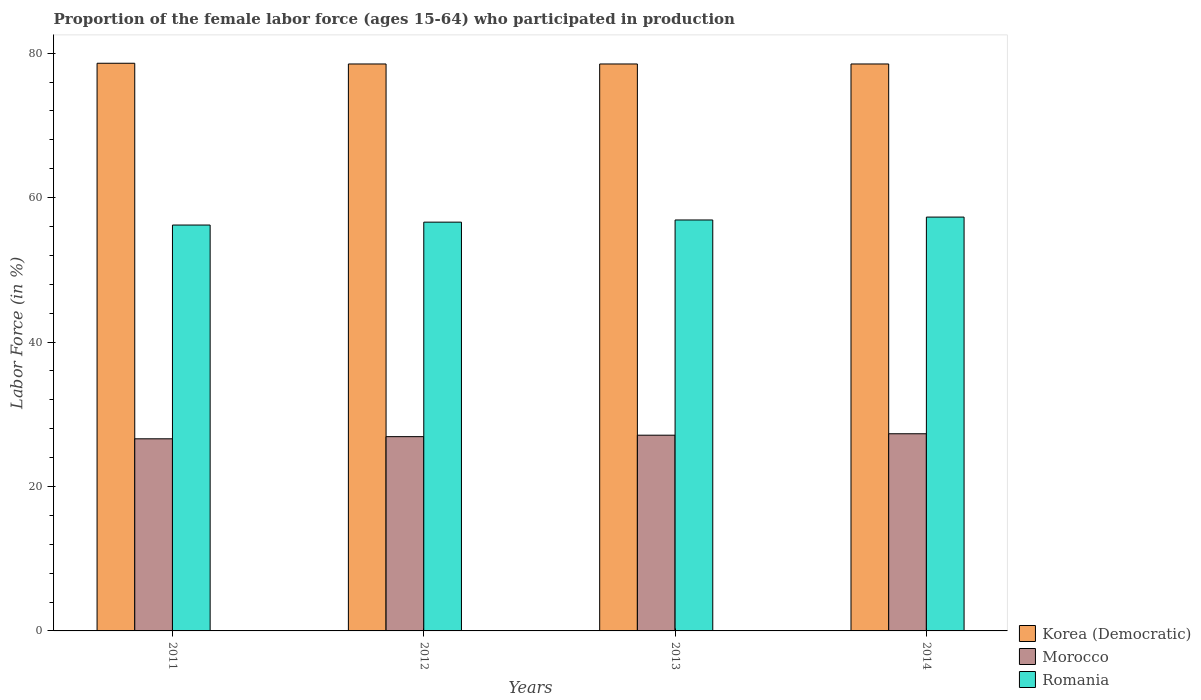How many groups of bars are there?
Keep it short and to the point. 4. What is the label of the 2nd group of bars from the left?
Offer a very short reply. 2012. In how many cases, is the number of bars for a given year not equal to the number of legend labels?
Offer a terse response. 0. What is the proportion of the female labor force who participated in production in Korea (Democratic) in 2013?
Make the answer very short. 78.5. Across all years, what is the maximum proportion of the female labor force who participated in production in Morocco?
Ensure brevity in your answer.  27.3. Across all years, what is the minimum proportion of the female labor force who participated in production in Korea (Democratic)?
Your answer should be compact. 78.5. In which year was the proportion of the female labor force who participated in production in Morocco maximum?
Your answer should be very brief. 2014. What is the total proportion of the female labor force who participated in production in Korea (Democratic) in the graph?
Provide a short and direct response. 314.1. What is the difference between the proportion of the female labor force who participated in production in Korea (Democratic) in 2012 and that in 2014?
Your answer should be compact. 0. What is the difference between the proportion of the female labor force who participated in production in Romania in 2014 and the proportion of the female labor force who participated in production in Korea (Democratic) in 2012?
Keep it short and to the point. -21.2. What is the average proportion of the female labor force who participated in production in Morocco per year?
Your response must be concise. 26.97. In the year 2012, what is the difference between the proportion of the female labor force who participated in production in Romania and proportion of the female labor force who participated in production in Korea (Democratic)?
Your answer should be very brief. -21.9. In how many years, is the proportion of the female labor force who participated in production in Romania greater than 44 %?
Give a very brief answer. 4. What is the ratio of the proportion of the female labor force who participated in production in Romania in 2013 to that in 2014?
Your response must be concise. 0.99. Is the proportion of the female labor force who participated in production in Romania in 2011 less than that in 2013?
Ensure brevity in your answer.  Yes. Is the difference between the proportion of the female labor force who participated in production in Romania in 2012 and 2014 greater than the difference between the proportion of the female labor force who participated in production in Korea (Democratic) in 2012 and 2014?
Provide a succinct answer. No. What is the difference between the highest and the second highest proportion of the female labor force who participated in production in Korea (Democratic)?
Keep it short and to the point. 0.1. What is the difference between the highest and the lowest proportion of the female labor force who participated in production in Romania?
Offer a very short reply. 1.1. In how many years, is the proportion of the female labor force who participated in production in Romania greater than the average proportion of the female labor force who participated in production in Romania taken over all years?
Your answer should be compact. 2. Is the sum of the proportion of the female labor force who participated in production in Romania in 2013 and 2014 greater than the maximum proportion of the female labor force who participated in production in Morocco across all years?
Your response must be concise. Yes. What does the 1st bar from the left in 2013 represents?
Make the answer very short. Korea (Democratic). What does the 2nd bar from the right in 2014 represents?
Provide a short and direct response. Morocco. Is it the case that in every year, the sum of the proportion of the female labor force who participated in production in Morocco and proportion of the female labor force who participated in production in Romania is greater than the proportion of the female labor force who participated in production in Korea (Democratic)?
Your answer should be compact. Yes. How many bars are there?
Your response must be concise. 12. What is the difference between two consecutive major ticks on the Y-axis?
Offer a terse response. 20. Are the values on the major ticks of Y-axis written in scientific E-notation?
Offer a very short reply. No. Does the graph contain any zero values?
Keep it short and to the point. No. How many legend labels are there?
Offer a terse response. 3. What is the title of the graph?
Provide a succinct answer. Proportion of the female labor force (ages 15-64) who participated in production. What is the label or title of the X-axis?
Make the answer very short. Years. What is the Labor Force (in %) in Korea (Democratic) in 2011?
Give a very brief answer. 78.6. What is the Labor Force (in %) of Morocco in 2011?
Provide a short and direct response. 26.6. What is the Labor Force (in %) in Romania in 2011?
Ensure brevity in your answer.  56.2. What is the Labor Force (in %) of Korea (Democratic) in 2012?
Give a very brief answer. 78.5. What is the Labor Force (in %) in Morocco in 2012?
Your response must be concise. 26.9. What is the Labor Force (in %) of Romania in 2012?
Your answer should be compact. 56.6. What is the Labor Force (in %) in Korea (Democratic) in 2013?
Offer a very short reply. 78.5. What is the Labor Force (in %) of Morocco in 2013?
Keep it short and to the point. 27.1. What is the Labor Force (in %) of Romania in 2013?
Provide a short and direct response. 56.9. What is the Labor Force (in %) of Korea (Democratic) in 2014?
Give a very brief answer. 78.5. What is the Labor Force (in %) of Morocco in 2014?
Your response must be concise. 27.3. What is the Labor Force (in %) in Romania in 2014?
Give a very brief answer. 57.3. Across all years, what is the maximum Labor Force (in %) of Korea (Democratic)?
Give a very brief answer. 78.6. Across all years, what is the maximum Labor Force (in %) in Morocco?
Give a very brief answer. 27.3. Across all years, what is the maximum Labor Force (in %) in Romania?
Provide a short and direct response. 57.3. Across all years, what is the minimum Labor Force (in %) of Korea (Democratic)?
Your answer should be compact. 78.5. Across all years, what is the minimum Labor Force (in %) in Morocco?
Make the answer very short. 26.6. Across all years, what is the minimum Labor Force (in %) in Romania?
Keep it short and to the point. 56.2. What is the total Labor Force (in %) of Korea (Democratic) in the graph?
Provide a succinct answer. 314.1. What is the total Labor Force (in %) in Morocco in the graph?
Provide a succinct answer. 107.9. What is the total Labor Force (in %) in Romania in the graph?
Provide a short and direct response. 227. What is the difference between the Labor Force (in %) in Korea (Democratic) in 2012 and that in 2013?
Provide a succinct answer. 0. What is the difference between the Labor Force (in %) in Morocco in 2012 and that in 2013?
Keep it short and to the point. -0.2. What is the difference between the Labor Force (in %) of Romania in 2012 and that in 2013?
Your answer should be very brief. -0.3. What is the difference between the Labor Force (in %) of Morocco in 2012 and that in 2014?
Keep it short and to the point. -0.4. What is the difference between the Labor Force (in %) of Korea (Democratic) in 2013 and that in 2014?
Your answer should be compact. 0. What is the difference between the Labor Force (in %) of Morocco in 2013 and that in 2014?
Provide a short and direct response. -0.2. What is the difference between the Labor Force (in %) of Korea (Democratic) in 2011 and the Labor Force (in %) of Morocco in 2012?
Give a very brief answer. 51.7. What is the difference between the Labor Force (in %) in Korea (Democratic) in 2011 and the Labor Force (in %) in Morocco in 2013?
Ensure brevity in your answer.  51.5. What is the difference between the Labor Force (in %) in Korea (Democratic) in 2011 and the Labor Force (in %) in Romania in 2013?
Keep it short and to the point. 21.7. What is the difference between the Labor Force (in %) in Morocco in 2011 and the Labor Force (in %) in Romania in 2013?
Provide a short and direct response. -30.3. What is the difference between the Labor Force (in %) of Korea (Democratic) in 2011 and the Labor Force (in %) of Morocco in 2014?
Your answer should be compact. 51.3. What is the difference between the Labor Force (in %) in Korea (Democratic) in 2011 and the Labor Force (in %) in Romania in 2014?
Your response must be concise. 21.3. What is the difference between the Labor Force (in %) of Morocco in 2011 and the Labor Force (in %) of Romania in 2014?
Keep it short and to the point. -30.7. What is the difference between the Labor Force (in %) in Korea (Democratic) in 2012 and the Labor Force (in %) in Morocco in 2013?
Make the answer very short. 51.4. What is the difference between the Labor Force (in %) in Korea (Democratic) in 2012 and the Labor Force (in %) in Romania in 2013?
Keep it short and to the point. 21.6. What is the difference between the Labor Force (in %) of Morocco in 2012 and the Labor Force (in %) of Romania in 2013?
Keep it short and to the point. -30. What is the difference between the Labor Force (in %) of Korea (Democratic) in 2012 and the Labor Force (in %) of Morocco in 2014?
Make the answer very short. 51.2. What is the difference between the Labor Force (in %) in Korea (Democratic) in 2012 and the Labor Force (in %) in Romania in 2014?
Give a very brief answer. 21.2. What is the difference between the Labor Force (in %) in Morocco in 2012 and the Labor Force (in %) in Romania in 2014?
Your response must be concise. -30.4. What is the difference between the Labor Force (in %) of Korea (Democratic) in 2013 and the Labor Force (in %) of Morocco in 2014?
Give a very brief answer. 51.2. What is the difference between the Labor Force (in %) in Korea (Democratic) in 2013 and the Labor Force (in %) in Romania in 2014?
Keep it short and to the point. 21.2. What is the difference between the Labor Force (in %) in Morocco in 2013 and the Labor Force (in %) in Romania in 2014?
Offer a terse response. -30.2. What is the average Labor Force (in %) of Korea (Democratic) per year?
Make the answer very short. 78.53. What is the average Labor Force (in %) of Morocco per year?
Give a very brief answer. 26.98. What is the average Labor Force (in %) of Romania per year?
Keep it short and to the point. 56.75. In the year 2011, what is the difference between the Labor Force (in %) in Korea (Democratic) and Labor Force (in %) in Romania?
Provide a succinct answer. 22.4. In the year 2011, what is the difference between the Labor Force (in %) of Morocco and Labor Force (in %) of Romania?
Your answer should be compact. -29.6. In the year 2012, what is the difference between the Labor Force (in %) in Korea (Democratic) and Labor Force (in %) in Morocco?
Your response must be concise. 51.6. In the year 2012, what is the difference between the Labor Force (in %) in Korea (Democratic) and Labor Force (in %) in Romania?
Offer a very short reply. 21.9. In the year 2012, what is the difference between the Labor Force (in %) of Morocco and Labor Force (in %) of Romania?
Make the answer very short. -29.7. In the year 2013, what is the difference between the Labor Force (in %) of Korea (Democratic) and Labor Force (in %) of Morocco?
Offer a terse response. 51.4. In the year 2013, what is the difference between the Labor Force (in %) of Korea (Democratic) and Labor Force (in %) of Romania?
Provide a succinct answer. 21.6. In the year 2013, what is the difference between the Labor Force (in %) of Morocco and Labor Force (in %) of Romania?
Your answer should be very brief. -29.8. In the year 2014, what is the difference between the Labor Force (in %) in Korea (Democratic) and Labor Force (in %) in Morocco?
Make the answer very short. 51.2. In the year 2014, what is the difference between the Labor Force (in %) in Korea (Democratic) and Labor Force (in %) in Romania?
Ensure brevity in your answer.  21.2. What is the ratio of the Labor Force (in %) of Korea (Democratic) in 2011 to that in 2013?
Provide a short and direct response. 1. What is the ratio of the Labor Force (in %) in Morocco in 2011 to that in 2013?
Offer a very short reply. 0.98. What is the ratio of the Labor Force (in %) of Korea (Democratic) in 2011 to that in 2014?
Your response must be concise. 1. What is the ratio of the Labor Force (in %) in Morocco in 2011 to that in 2014?
Your response must be concise. 0.97. What is the ratio of the Labor Force (in %) of Romania in 2011 to that in 2014?
Offer a very short reply. 0.98. What is the ratio of the Labor Force (in %) of Korea (Democratic) in 2012 to that in 2014?
Your response must be concise. 1. What is the ratio of the Labor Force (in %) of Romania in 2013 to that in 2014?
Offer a very short reply. 0.99. What is the difference between the highest and the second highest Labor Force (in %) in Morocco?
Give a very brief answer. 0.2. What is the difference between the highest and the second highest Labor Force (in %) in Romania?
Your answer should be compact. 0.4. 